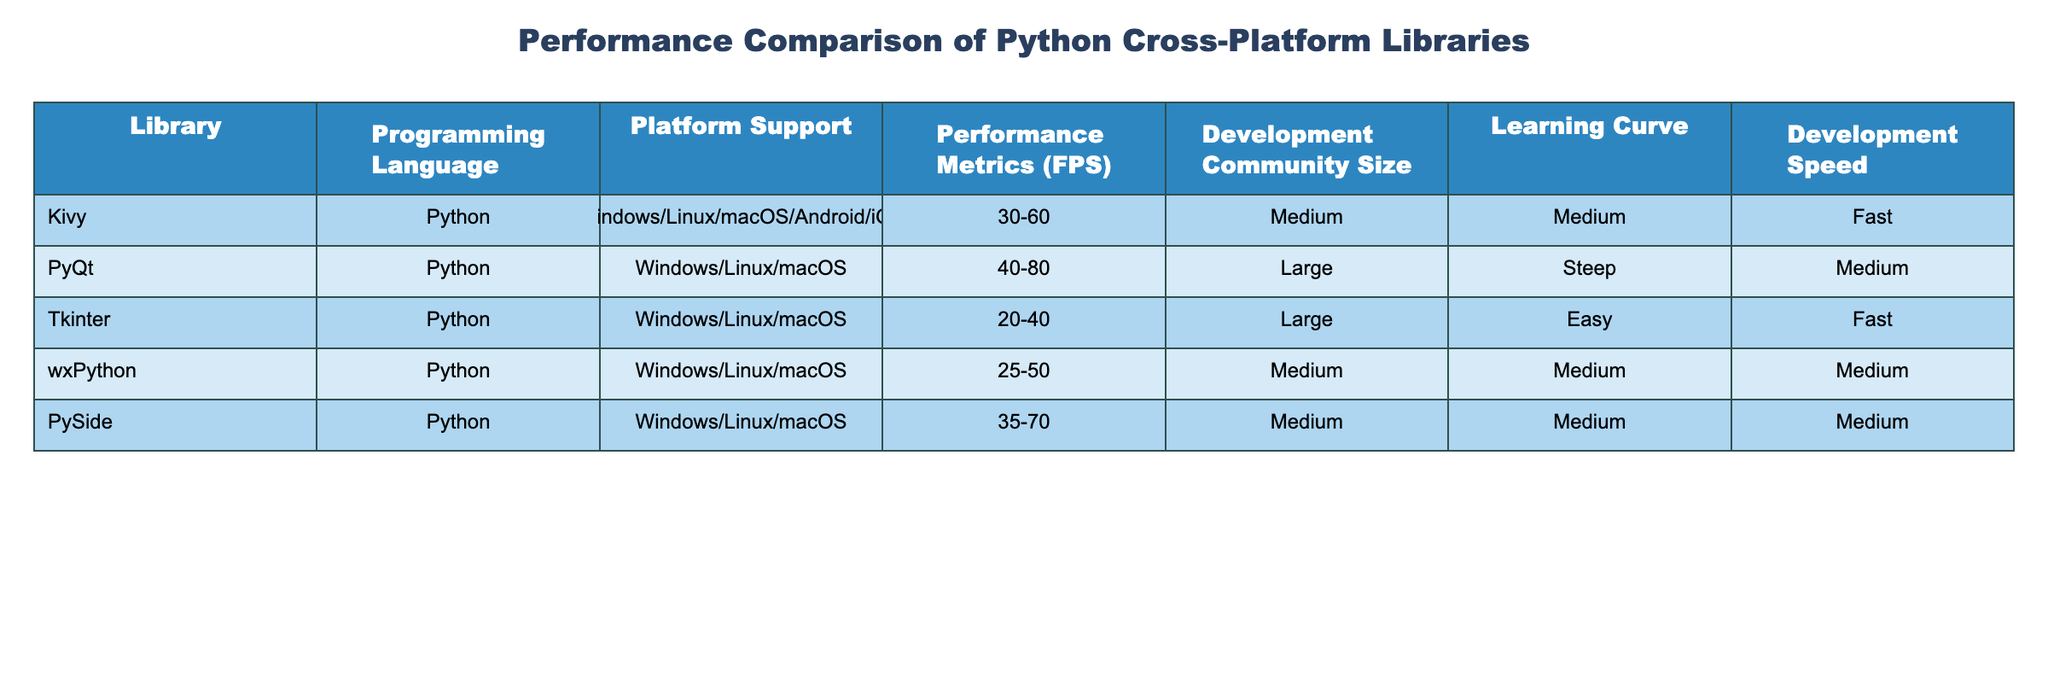What is the performance range (FPS) for Kivy? The table states that Kivy has a performance range of 30-60 FPS. To find this, I can look directly at the 'Performance Metrics (FPS)' column corresponding to Kivy.
Answer: 30-60 Which library has the highest performance metric (FPS) range? I need to compare the performance metrics of all libraries. The performance ranges from the table are 30-60 for Kivy, 40-80 for PyQt, 20-40 for Tkinter, 25-50 for wxPython, and 35-70 for PySide. The range of PyQt (40-80) is the highest, indicating it offers the best performance.
Answer: PyQt Is the development speed for Tkinter listed as fast? The table shows that the development speed for Tkinter is categorized as 'Fast'. I check the corresponding entry in the 'Development Speed' column for Tkinter to confirm this.
Answer: Yes What is the average performance (FPS) of the libraries? To determine the average performance, I sum the midpoint of each performance range: Kivy (45), PyQt (60), Tkinter (30), wxPython (37.5), and PySide (52.5). The total is 225, and dividing by 5 gives an average of 45 FPS. I calculated the midpoint for each range by taking the average of the lower and upper bounds.
Answer: 45 Does Kivy have a larger development community size than wxPython? I check the 'Development Community Size' column for both Kivy and wxPython. Kivy is categorized as 'Medium', whereas wxPython is categorized as 'Medium' as well. Since both are the same, the answer is no.
Answer: No What is the development curve for PyQt compared to PySide? I review the 'Learning Curve' column; PyQt has a 'Steep' learning curve while PySide is 'Medium'. PyQt has a steeper learning curve than PySide.
Answer: PyQt has a steeper learning curve Which library supports the most platforms? By examining the 'Platform Support' column, I see that Kivy supports Windows, Linux, macOS, Android, and iOS, which is five platforms. The other libraries support fewer platforms. Therefore, Kivy supports the most platforms.
Answer: Kivy If I want a library with large development community size and fast development speed, which one should I choose? I refer to both the 'Development Community Size' and 'Development Speed' columns. Tkinter has a large development community and fast development speed, while PyQt and wxPython have large communities but not fast development speed. Tkinter meets both criteria.
Answer: Tkinter What is the difference in performance (FPS) between PyQt and Kivy? The range for PyQt is 40-80 and Kivy is 30-60. To find the difference, I calculate the average for both: PyQt (60) - Kivy (45) = 15 FPS. Therefore, the performance difference is 15 FPS.
Answer: 15 FPS 